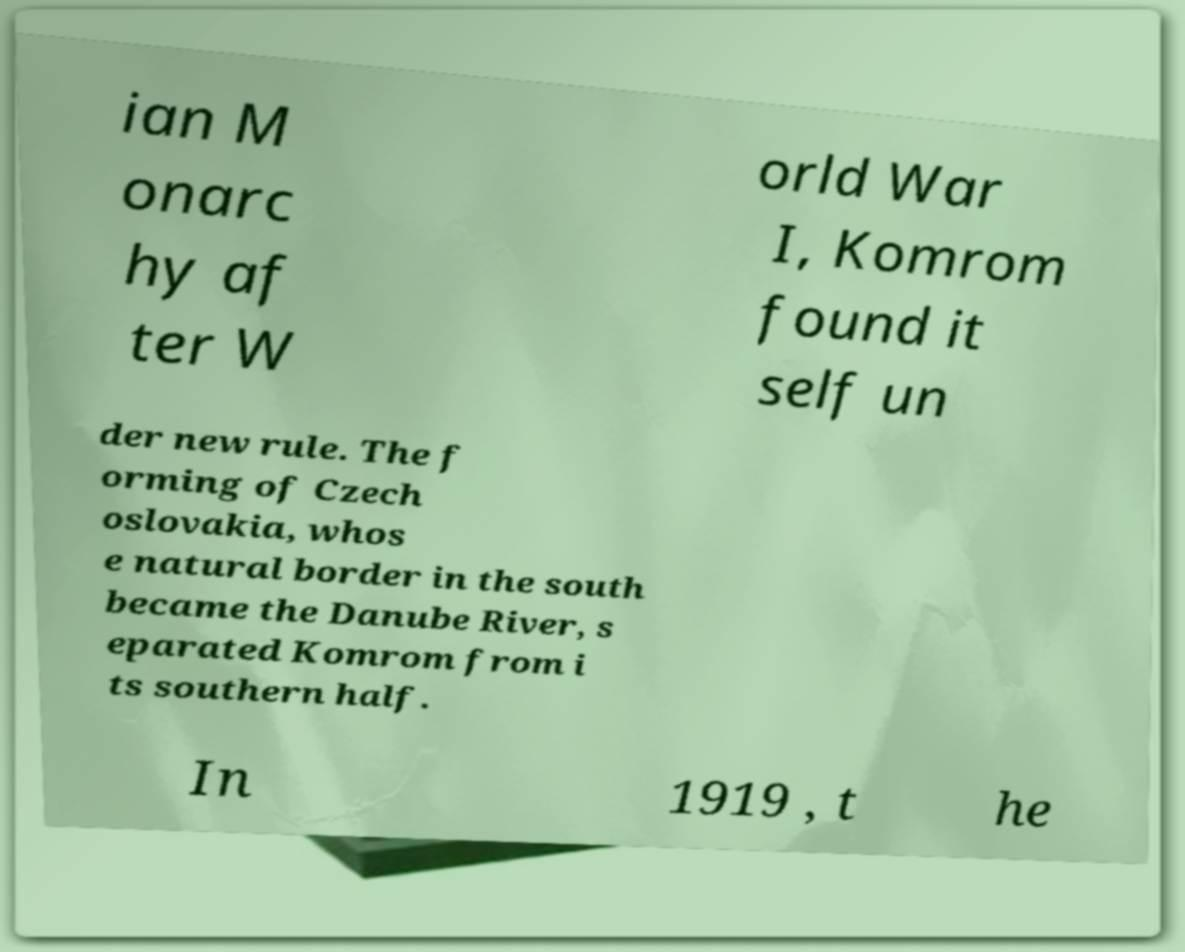Could you extract and type out the text from this image? ian M onarc hy af ter W orld War I, Komrom found it self un der new rule. The f orming of Czech oslovakia, whos e natural border in the south became the Danube River, s eparated Komrom from i ts southern half. In 1919 , t he 